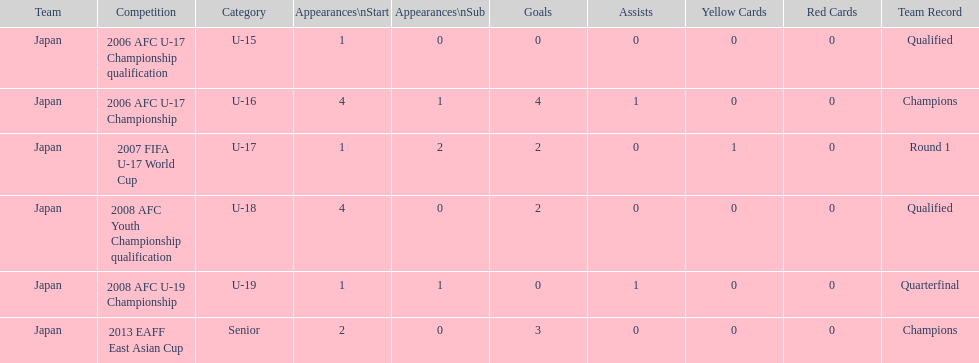Where did japan only score four goals? 2006 AFC U-17 Championship. 